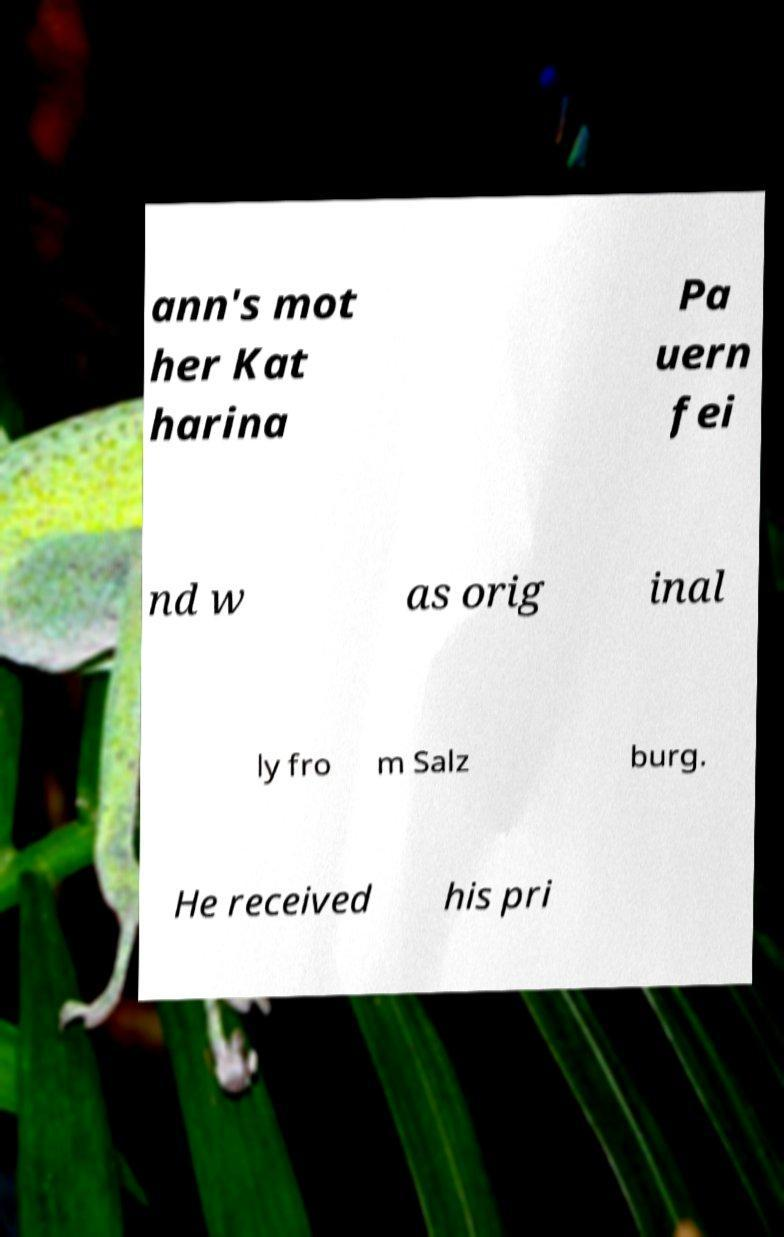I need the written content from this picture converted into text. Can you do that? ann's mot her Kat harina Pa uern fei nd w as orig inal ly fro m Salz burg. He received his pri 